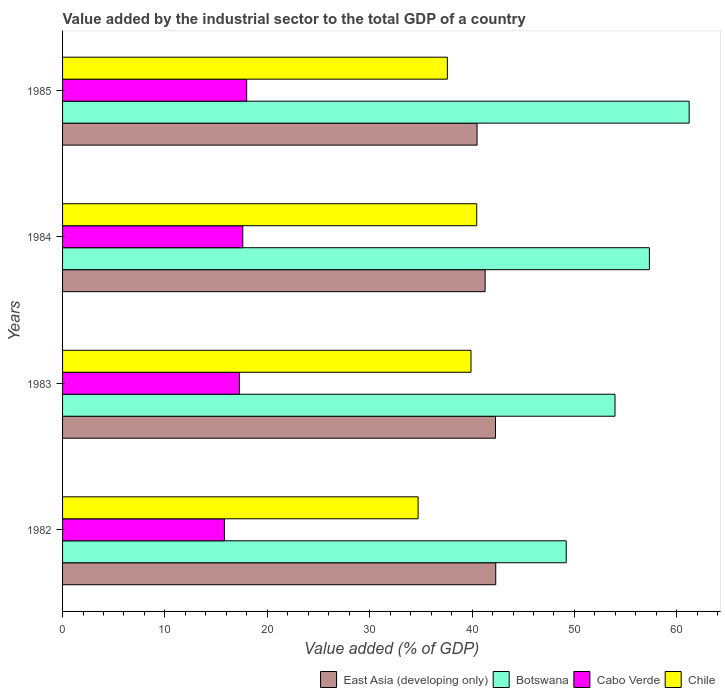How many different coloured bars are there?
Offer a very short reply. 4. Are the number of bars per tick equal to the number of legend labels?
Give a very brief answer. Yes. How many bars are there on the 2nd tick from the top?
Offer a very short reply. 4. How many bars are there on the 4th tick from the bottom?
Give a very brief answer. 4. What is the label of the 4th group of bars from the top?
Make the answer very short. 1982. In how many cases, is the number of bars for a given year not equal to the number of legend labels?
Your answer should be compact. 0. What is the value added by the industrial sector to the total GDP in Botswana in 1983?
Your answer should be compact. 53.96. Across all years, what is the maximum value added by the industrial sector to the total GDP in East Asia (developing only)?
Keep it short and to the point. 42.31. Across all years, what is the minimum value added by the industrial sector to the total GDP in East Asia (developing only)?
Your response must be concise. 40.49. In which year was the value added by the industrial sector to the total GDP in Cabo Verde maximum?
Make the answer very short. 1985. In which year was the value added by the industrial sector to the total GDP in East Asia (developing only) minimum?
Keep it short and to the point. 1985. What is the total value added by the industrial sector to the total GDP in Cabo Verde in the graph?
Make the answer very short. 68.67. What is the difference between the value added by the industrial sector to the total GDP in East Asia (developing only) in 1982 and that in 1984?
Offer a very short reply. 1.04. What is the difference between the value added by the industrial sector to the total GDP in Chile in 1985 and the value added by the industrial sector to the total GDP in East Asia (developing only) in 1983?
Make the answer very short. -4.7. What is the average value added by the industrial sector to the total GDP in Botswana per year?
Give a very brief answer. 55.42. In the year 1982, what is the difference between the value added by the industrial sector to the total GDP in Botswana and value added by the industrial sector to the total GDP in East Asia (developing only)?
Your answer should be compact. 6.88. What is the ratio of the value added by the industrial sector to the total GDP in East Asia (developing only) in 1982 to that in 1983?
Give a very brief answer. 1. Is the difference between the value added by the industrial sector to the total GDP in Botswana in 1983 and 1985 greater than the difference between the value added by the industrial sector to the total GDP in East Asia (developing only) in 1983 and 1985?
Provide a short and direct response. No. What is the difference between the highest and the second highest value added by the industrial sector to the total GDP in East Asia (developing only)?
Ensure brevity in your answer.  0.02. What is the difference between the highest and the lowest value added by the industrial sector to the total GDP in Botswana?
Your response must be concise. 12.01. Is the sum of the value added by the industrial sector to the total GDP in Cabo Verde in 1984 and 1985 greater than the maximum value added by the industrial sector to the total GDP in Chile across all years?
Ensure brevity in your answer.  No. What does the 3rd bar from the bottom in 1982 represents?
Provide a short and direct response. Cabo Verde. Are the values on the major ticks of X-axis written in scientific E-notation?
Provide a succinct answer. No. Does the graph contain any zero values?
Provide a short and direct response. No. Where does the legend appear in the graph?
Ensure brevity in your answer.  Bottom right. How many legend labels are there?
Keep it short and to the point. 4. How are the legend labels stacked?
Offer a terse response. Horizontal. What is the title of the graph?
Your answer should be very brief. Value added by the industrial sector to the total GDP of a country. Does "Montenegro" appear as one of the legend labels in the graph?
Your response must be concise. No. What is the label or title of the X-axis?
Your answer should be compact. Value added (% of GDP). What is the label or title of the Y-axis?
Keep it short and to the point. Years. What is the Value added (% of GDP) in East Asia (developing only) in 1982?
Keep it short and to the point. 42.31. What is the Value added (% of GDP) of Botswana in 1982?
Your response must be concise. 49.2. What is the Value added (% of GDP) of Cabo Verde in 1982?
Give a very brief answer. 15.81. What is the Value added (% of GDP) of Chile in 1982?
Your answer should be compact. 34.73. What is the Value added (% of GDP) in East Asia (developing only) in 1983?
Ensure brevity in your answer.  42.29. What is the Value added (% of GDP) in Botswana in 1983?
Your response must be concise. 53.96. What is the Value added (% of GDP) in Cabo Verde in 1983?
Provide a short and direct response. 17.28. What is the Value added (% of GDP) in Chile in 1983?
Your answer should be very brief. 39.89. What is the Value added (% of GDP) of East Asia (developing only) in 1984?
Make the answer very short. 41.27. What is the Value added (% of GDP) of Botswana in 1984?
Your response must be concise. 57.32. What is the Value added (% of GDP) in Cabo Verde in 1984?
Your answer should be very brief. 17.6. What is the Value added (% of GDP) in Chile in 1984?
Provide a short and direct response. 40.46. What is the Value added (% of GDP) of East Asia (developing only) in 1985?
Offer a very short reply. 40.49. What is the Value added (% of GDP) of Botswana in 1985?
Provide a succinct answer. 61.21. What is the Value added (% of GDP) in Cabo Verde in 1985?
Offer a terse response. 17.98. What is the Value added (% of GDP) in Chile in 1985?
Offer a terse response. 37.59. Across all years, what is the maximum Value added (% of GDP) in East Asia (developing only)?
Provide a succinct answer. 42.31. Across all years, what is the maximum Value added (% of GDP) in Botswana?
Your response must be concise. 61.21. Across all years, what is the maximum Value added (% of GDP) in Cabo Verde?
Your response must be concise. 17.98. Across all years, what is the maximum Value added (% of GDP) of Chile?
Ensure brevity in your answer.  40.46. Across all years, what is the minimum Value added (% of GDP) in East Asia (developing only)?
Offer a very short reply. 40.49. Across all years, what is the minimum Value added (% of GDP) of Botswana?
Your answer should be compact. 49.2. Across all years, what is the minimum Value added (% of GDP) of Cabo Verde?
Make the answer very short. 15.81. Across all years, what is the minimum Value added (% of GDP) in Chile?
Offer a terse response. 34.73. What is the total Value added (% of GDP) of East Asia (developing only) in the graph?
Your answer should be very brief. 166.36. What is the total Value added (% of GDP) of Botswana in the graph?
Offer a very short reply. 221.68. What is the total Value added (% of GDP) in Cabo Verde in the graph?
Offer a very short reply. 68.67. What is the total Value added (% of GDP) in Chile in the graph?
Provide a succinct answer. 152.66. What is the difference between the Value added (% of GDP) in East Asia (developing only) in 1982 and that in 1983?
Your answer should be compact. 0.02. What is the difference between the Value added (% of GDP) in Botswana in 1982 and that in 1983?
Keep it short and to the point. -4.77. What is the difference between the Value added (% of GDP) of Cabo Verde in 1982 and that in 1983?
Offer a terse response. -1.47. What is the difference between the Value added (% of GDP) of Chile in 1982 and that in 1983?
Your response must be concise. -5.17. What is the difference between the Value added (% of GDP) in East Asia (developing only) in 1982 and that in 1984?
Make the answer very short. 1.04. What is the difference between the Value added (% of GDP) of Botswana in 1982 and that in 1984?
Your answer should be compact. -8.13. What is the difference between the Value added (% of GDP) of Cabo Verde in 1982 and that in 1984?
Ensure brevity in your answer.  -1.79. What is the difference between the Value added (% of GDP) of Chile in 1982 and that in 1984?
Your answer should be very brief. -5.73. What is the difference between the Value added (% of GDP) in East Asia (developing only) in 1982 and that in 1985?
Your response must be concise. 1.83. What is the difference between the Value added (% of GDP) of Botswana in 1982 and that in 1985?
Your answer should be compact. -12.01. What is the difference between the Value added (% of GDP) in Cabo Verde in 1982 and that in 1985?
Your answer should be compact. -2.17. What is the difference between the Value added (% of GDP) in Chile in 1982 and that in 1985?
Your response must be concise. -2.86. What is the difference between the Value added (% of GDP) in East Asia (developing only) in 1983 and that in 1984?
Your answer should be compact. 1.01. What is the difference between the Value added (% of GDP) in Botswana in 1983 and that in 1984?
Provide a short and direct response. -3.36. What is the difference between the Value added (% of GDP) in Cabo Verde in 1983 and that in 1984?
Make the answer very short. -0.33. What is the difference between the Value added (% of GDP) of Chile in 1983 and that in 1984?
Offer a very short reply. -0.56. What is the difference between the Value added (% of GDP) in East Asia (developing only) in 1983 and that in 1985?
Ensure brevity in your answer.  1.8. What is the difference between the Value added (% of GDP) of Botswana in 1983 and that in 1985?
Your answer should be very brief. -7.24. What is the difference between the Value added (% of GDP) in Cabo Verde in 1983 and that in 1985?
Your answer should be very brief. -0.71. What is the difference between the Value added (% of GDP) in Chile in 1983 and that in 1985?
Offer a very short reply. 2.31. What is the difference between the Value added (% of GDP) in East Asia (developing only) in 1984 and that in 1985?
Provide a succinct answer. 0.79. What is the difference between the Value added (% of GDP) of Botswana in 1984 and that in 1985?
Offer a very short reply. -3.88. What is the difference between the Value added (% of GDP) in Cabo Verde in 1984 and that in 1985?
Provide a succinct answer. -0.38. What is the difference between the Value added (% of GDP) in Chile in 1984 and that in 1985?
Provide a succinct answer. 2.87. What is the difference between the Value added (% of GDP) of East Asia (developing only) in 1982 and the Value added (% of GDP) of Botswana in 1983?
Keep it short and to the point. -11.65. What is the difference between the Value added (% of GDP) in East Asia (developing only) in 1982 and the Value added (% of GDP) in Cabo Verde in 1983?
Offer a very short reply. 25.03. What is the difference between the Value added (% of GDP) in East Asia (developing only) in 1982 and the Value added (% of GDP) in Chile in 1983?
Provide a succinct answer. 2.42. What is the difference between the Value added (% of GDP) of Botswana in 1982 and the Value added (% of GDP) of Cabo Verde in 1983?
Offer a very short reply. 31.92. What is the difference between the Value added (% of GDP) of Botswana in 1982 and the Value added (% of GDP) of Chile in 1983?
Provide a succinct answer. 9.3. What is the difference between the Value added (% of GDP) in Cabo Verde in 1982 and the Value added (% of GDP) in Chile in 1983?
Offer a very short reply. -24.08. What is the difference between the Value added (% of GDP) in East Asia (developing only) in 1982 and the Value added (% of GDP) in Botswana in 1984?
Offer a terse response. -15.01. What is the difference between the Value added (% of GDP) of East Asia (developing only) in 1982 and the Value added (% of GDP) of Cabo Verde in 1984?
Your answer should be very brief. 24.71. What is the difference between the Value added (% of GDP) in East Asia (developing only) in 1982 and the Value added (% of GDP) in Chile in 1984?
Your response must be concise. 1.86. What is the difference between the Value added (% of GDP) in Botswana in 1982 and the Value added (% of GDP) in Cabo Verde in 1984?
Your response must be concise. 31.59. What is the difference between the Value added (% of GDP) in Botswana in 1982 and the Value added (% of GDP) in Chile in 1984?
Provide a short and direct response. 8.74. What is the difference between the Value added (% of GDP) in Cabo Verde in 1982 and the Value added (% of GDP) in Chile in 1984?
Ensure brevity in your answer.  -24.65. What is the difference between the Value added (% of GDP) of East Asia (developing only) in 1982 and the Value added (% of GDP) of Botswana in 1985?
Your answer should be compact. -18.89. What is the difference between the Value added (% of GDP) in East Asia (developing only) in 1982 and the Value added (% of GDP) in Cabo Verde in 1985?
Provide a succinct answer. 24.33. What is the difference between the Value added (% of GDP) in East Asia (developing only) in 1982 and the Value added (% of GDP) in Chile in 1985?
Provide a short and direct response. 4.72. What is the difference between the Value added (% of GDP) of Botswana in 1982 and the Value added (% of GDP) of Cabo Verde in 1985?
Your answer should be very brief. 31.21. What is the difference between the Value added (% of GDP) of Botswana in 1982 and the Value added (% of GDP) of Chile in 1985?
Your response must be concise. 11.61. What is the difference between the Value added (% of GDP) in Cabo Verde in 1982 and the Value added (% of GDP) in Chile in 1985?
Ensure brevity in your answer.  -21.78. What is the difference between the Value added (% of GDP) of East Asia (developing only) in 1983 and the Value added (% of GDP) of Botswana in 1984?
Offer a very short reply. -15.03. What is the difference between the Value added (% of GDP) of East Asia (developing only) in 1983 and the Value added (% of GDP) of Cabo Verde in 1984?
Ensure brevity in your answer.  24.68. What is the difference between the Value added (% of GDP) of East Asia (developing only) in 1983 and the Value added (% of GDP) of Chile in 1984?
Keep it short and to the point. 1.83. What is the difference between the Value added (% of GDP) in Botswana in 1983 and the Value added (% of GDP) in Cabo Verde in 1984?
Offer a very short reply. 36.36. What is the difference between the Value added (% of GDP) of Botswana in 1983 and the Value added (% of GDP) of Chile in 1984?
Give a very brief answer. 13.51. What is the difference between the Value added (% of GDP) of Cabo Verde in 1983 and the Value added (% of GDP) of Chile in 1984?
Provide a succinct answer. -23.18. What is the difference between the Value added (% of GDP) of East Asia (developing only) in 1983 and the Value added (% of GDP) of Botswana in 1985?
Provide a succinct answer. -18.92. What is the difference between the Value added (% of GDP) in East Asia (developing only) in 1983 and the Value added (% of GDP) in Cabo Verde in 1985?
Give a very brief answer. 24.3. What is the difference between the Value added (% of GDP) in East Asia (developing only) in 1983 and the Value added (% of GDP) in Chile in 1985?
Offer a very short reply. 4.7. What is the difference between the Value added (% of GDP) in Botswana in 1983 and the Value added (% of GDP) in Cabo Verde in 1985?
Your response must be concise. 35.98. What is the difference between the Value added (% of GDP) in Botswana in 1983 and the Value added (% of GDP) in Chile in 1985?
Your response must be concise. 16.37. What is the difference between the Value added (% of GDP) in Cabo Verde in 1983 and the Value added (% of GDP) in Chile in 1985?
Offer a very short reply. -20.31. What is the difference between the Value added (% of GDP) in East Asia (developing only) in 1984 and the Value added (% of GDP) in Botswana in 1985?
Make the answer very short. -19.93. What is the difference between the Value added (% of GDP) in East Asia (developing only) in 1984 and the Value added (% of GDP) in Cabo Verde in 1985?
Provide a succinct answer. 23.29. What is the difference between the Value added (% of GDP) in East Asia (developing only) in 1984 and the Value added (% of GDP) in Chile in 1985?
Provide a succinct answer. 3.69. What is the difference between the Value added (% of GDP) in Botswana in 1984 and the Value added (% of GDP) in Cabo Verde in 1985?
Give a very brief answer. 39.34. What is the difference between the Value added (% of GDP) in Botswana in 1984 and the Value added (% of GDP) in Chile in 1985?
Ensure brevity in your answer.  19.73. What is the difference between the Value added (% of GDP) of Cabo Verde in 1984 and the Value added (% of GDP) of Chile in 1985?
Keep it short and to the point. -19.98. What is the average Value added (% of GDP) in East Asia (developing only) per year?
Your answer should be very brief. 41.59. What is the average Value added (% of GDP) in Botswana per year?
Your answer should be very brief. 55.42. What is the average Value added (% of GDP) of Cabo Verde per year?
Your answer should be very brief. 17.17. What is the average Value added (% of GDP) of Chile per year?
Keep it short and to the point. 38.17. In the year 1982, what is the difference between the Value added (% of GDP) in East Asia (developing only) and Value added (% of GDP) in Botswana?
Give a very brief answer. -6.88. In the year 1982, what is the difference between the Value added (% of GDP) in East Asia (developing only) and Value added (% of GDP) in Cabo Verde?
Keep it short and to the point. 26.5. In the year 1982, what is the difference between the Value added (% of GDP) in East Asia (developing only) and Value added (% of GDP) in Chile?
Your answer should be compact. 7.58. In the year 1982, what is the difference between the Value added (% of GDP) of Botswana and Value added (% of GDP) of Cabo Verde?
Your response must be concise. 33.39. In the year 1982, what is the difference between the Value added (% of GDP) in Botswana and Value added (% of GDP) in Chile?
Give a very brief answer. 14.47. In the year 1982, what is the difference between the Value added (% of GDP) of Cabo Verde and Value added (% of GDP) of Chile?
Offer a very short reply. -18.92. In the year 1983, what is the difference between the Value added (% of GDP) of East Asia (developing only) and Value added (% of GDP) of Botswana?
Offer a terse response. -11.67. In the year 1983, what is the difference between the Value added (% of GDP) in East Asia (developing only) and Value added (% of GDP) in Cabo Verde?
Your answer should be compact. 25.01. In the year 1983, what is the difference between the Value added (% of GDP) in East Asia (developing only) and Value added (% of GDP) in Chile?
Your answer should be very brief. 2.4. In the year 1983, what is the difference between the Value added (% of GDP) in Botswana and Value added (% of GDP) in Cabo Verde?
Give a very brief answer. 36.68. In the year 1983, what is the difference between the Value added (% of GDP) of Botswana and Value added (% of GDP) of Chile?
Provide a short and direct response. 14.07. In the year 1983, what is the difference between the Value added (% of GDP) in Cabo Verde and Value added (% of GDP) in Chile?
Ensure brevity in your answer.  -22.62. In the year 1984, what is the difference between the Value added (% of GDP) of East Asia (developing only) and Value added (% of GDP) of Botswana?
Give a very brief answer. -16.05. In the year 1984, what is the difference between the Value added (% of GDP) in East Asia (developing only) and Value added (% of GDP) in Cabo Verde?
Ensure brevity in your answer.  23.67. In the year 1984, what is the difference between the Value added (% of GDP) in East Asia (developing only) and Value added (% of GDP) in Chile?
Provide a short and direct response. 0.82. In the year 1984, what is the difference between the Value added (% of GDP) of Botswana and Value added (% of GDP) of Cabo Verde?
Keep it short and to the point. 39.72. In the year 1984, what is the difference between the Value added (% of GDP) of Botswana and Value added (% of GDP) of Chile?
Keep it short and to the point. 16.87. In the year 1984, what is the difference between the Value added (% of GDP) of Cabo Verde and Value added (% of GDP) of Chile?
Give a very brief answer. -22.85. In the year 1985, what is the difference between the Value added (% of GDP) in East Asia (developing only) and Value added (% of GDP) in Botswana?
Offer a very short reply. -20.72. In the year 1985, what is the difference between the Value added (% of GDP) of East Asia (developing only) and Value added (% of GDP) of Cabo Verde?
Your answer should be compact. 22.5. In the year 1985, what is the difference between the Value added (% of GDP) in East Asia (developing only) and Value added (% of GDP) in Chile?
Your answer should be compact. 2.9. In the year 1985, what is the difference between the Value added (% of GDP) of Botswana and Value added (% of GDP) of Cabo Verde?
Give a very brief answer. 43.22. In the year 1985, what is the difference between the Value added (% of GDP) of Botswana and Value added (% of GDP) of Chile?
Make the answer very short. 23.62. In the year 1985, what is the difference between the Value added (% of GDP) in Cabo Verde and Value added (% of GDP) in Chile?
Ensure brevity in your answer.  -19.6. What is the ratio of the Value added (% of GDP) of East Asia (developing only) in 1982 to that in 1983?
Ensure brevity in your answer.  1. What is the ratio of the Value added (% of GDP) in Botswana in 1982 to that in 1983?
Give a very brief answer. 0.91. What is the ratio of the Value added (% of GDP) in Cabo Verde in 1982 to that in 1983?
Your response must be concise. 0.92. What is the ratio of the Value added (% of GDP) of Chile in 1982 to that in 1983?
Your response must be concise. 0.87. What is the ratio of the Value added (% of GDP) in East Asia (developing only) in 1982 to that in 1984?
Provide a short and direct response. 1.03. What is the ratio of the Value added (% of GDP) of Botswana in 1982 to that in 1984?
Your answer should be very brief. 0.86. What is the ratio of the Value added (% of GDP) of Cabo Verde in 1982 to that in 1984?
Provide a short and direct response. 0.9. What is the ratio of the Value added (% of GDP) in Chile in 1982 to that in 1984?
Provide a short and direct response. 0.86. What is the ratio of the Value added (% of GDP) of East Asia (developing only) in 1982 to that in 1985?
Offer a terse response. 1.05. What is the ratio of the Value added (% of GDP) of Botswana in 1982 to that in 1985?
Your answer should be compact. 0.8. What is the ratio of the Value added (% of GDP) of Cabo Verde in 1982 to that in 1985?
Your answer should be very brief. 0.88. What is the ratio of the Value added (% of GDP) of Chile in 1982 to that in 1985?
Offer a very short reply. 0.92. What is the ratio of the Value added (% of GDP) of East Asia (developing only) in 1983 to that in 1984?
Make the answer very short. 1.02. What is the ratio of the Value added (% of GDP) in Botswana in 1983 to that in 1984?
Offer a terse response. 0.94. What is the ratio of the Value added (% of GDP) of Cabo Verde in 1983 to that in 1984?
Provide a short and direct response. 0.98. What is the ratio of the Value added (% of GDP) of Chile in 1983 to that in 1984?
Ensure brevity in your answer.  0.99. What is the ratio of the Value added (% of GDP) in East Asia (developing only) in 1983 to that in 1985?
Your answer should be compact. 1.04. What is the ratio of the Value added (% of GDP) of Botswana in 1983 to that in 1985?
Your answer should be very brief. 0.88. What is the ratio of the Value added (% of GDP) in Cabo Verde in 1983 to that in 1985?
Give a very brief answer. 0.96. What is the ratio of the Value added (% of GDP) in Chile in 1983 to that in 1985?
Make the answer very short. 1.06. What is the ratio of the Value added (% of GDP) of East Asia (developing only) in 1984 to that in 1985?
Make the answer very short. 1.02. What is the ratio of the Value added (% of GDP) in Botswana in 1984 to that in 1985?
Provide a succinct answer. 0.94. What is the ratio of the Value added (% of GDP) of Cabo Verde in 1984 to that in 1985?
Offer a very short reply. 0.98. What is the ratio of the Value added (% of GDP) of Chile in 1984 to that in 1985?
Provide a short and direct response. 1.08. What is the difference between the highest and the second highest Value added (% of GDP) of East Asia (developing only)?
Provide a succinct answer. 0.02. What is the difference between the highest and the second highest Value added (% of GDP) in Botswana?
Ensure brevity in your answer.  3.88. What is the difference between the highest and the second highest Value added (% of GDP) in Cabo Verde?
Offer a terse response. 0.38. What is the difference between the highest and the second highest Value added (% of GDP) of Chile?
Give a very brief answer. 0.56. What is the difference between the highest and the lowest Value added (% of GDP) in East Asia (developing only)?
Make the answer very short. 1.83. What is the difference between the highest and the lowest Value added (% of GDP) of Botswana?
Provide a short and direct response. 12.01. What is the difference between the highest and the lowest Value added (% of GDP) of Cabo Verde?
Keep it short and to the point. 2.17. What is the difference between the highest and the lowest Value added (% of GDP) of Chile?
Provide a short and direct response. 5.73. 